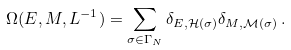Convert formula to latex. <formula><loc_0><loc_0><loc_500><loc_500>\Omega ( E , M , L ^ { - 1 } ) = \sum _ { \sigma \in \Gamma _ { N } } \delta _ { E , \mathcal { H } ( \sigma ) } \delta _ { M , \mathcal { M } ( \sigma ) } \, .</formula> 